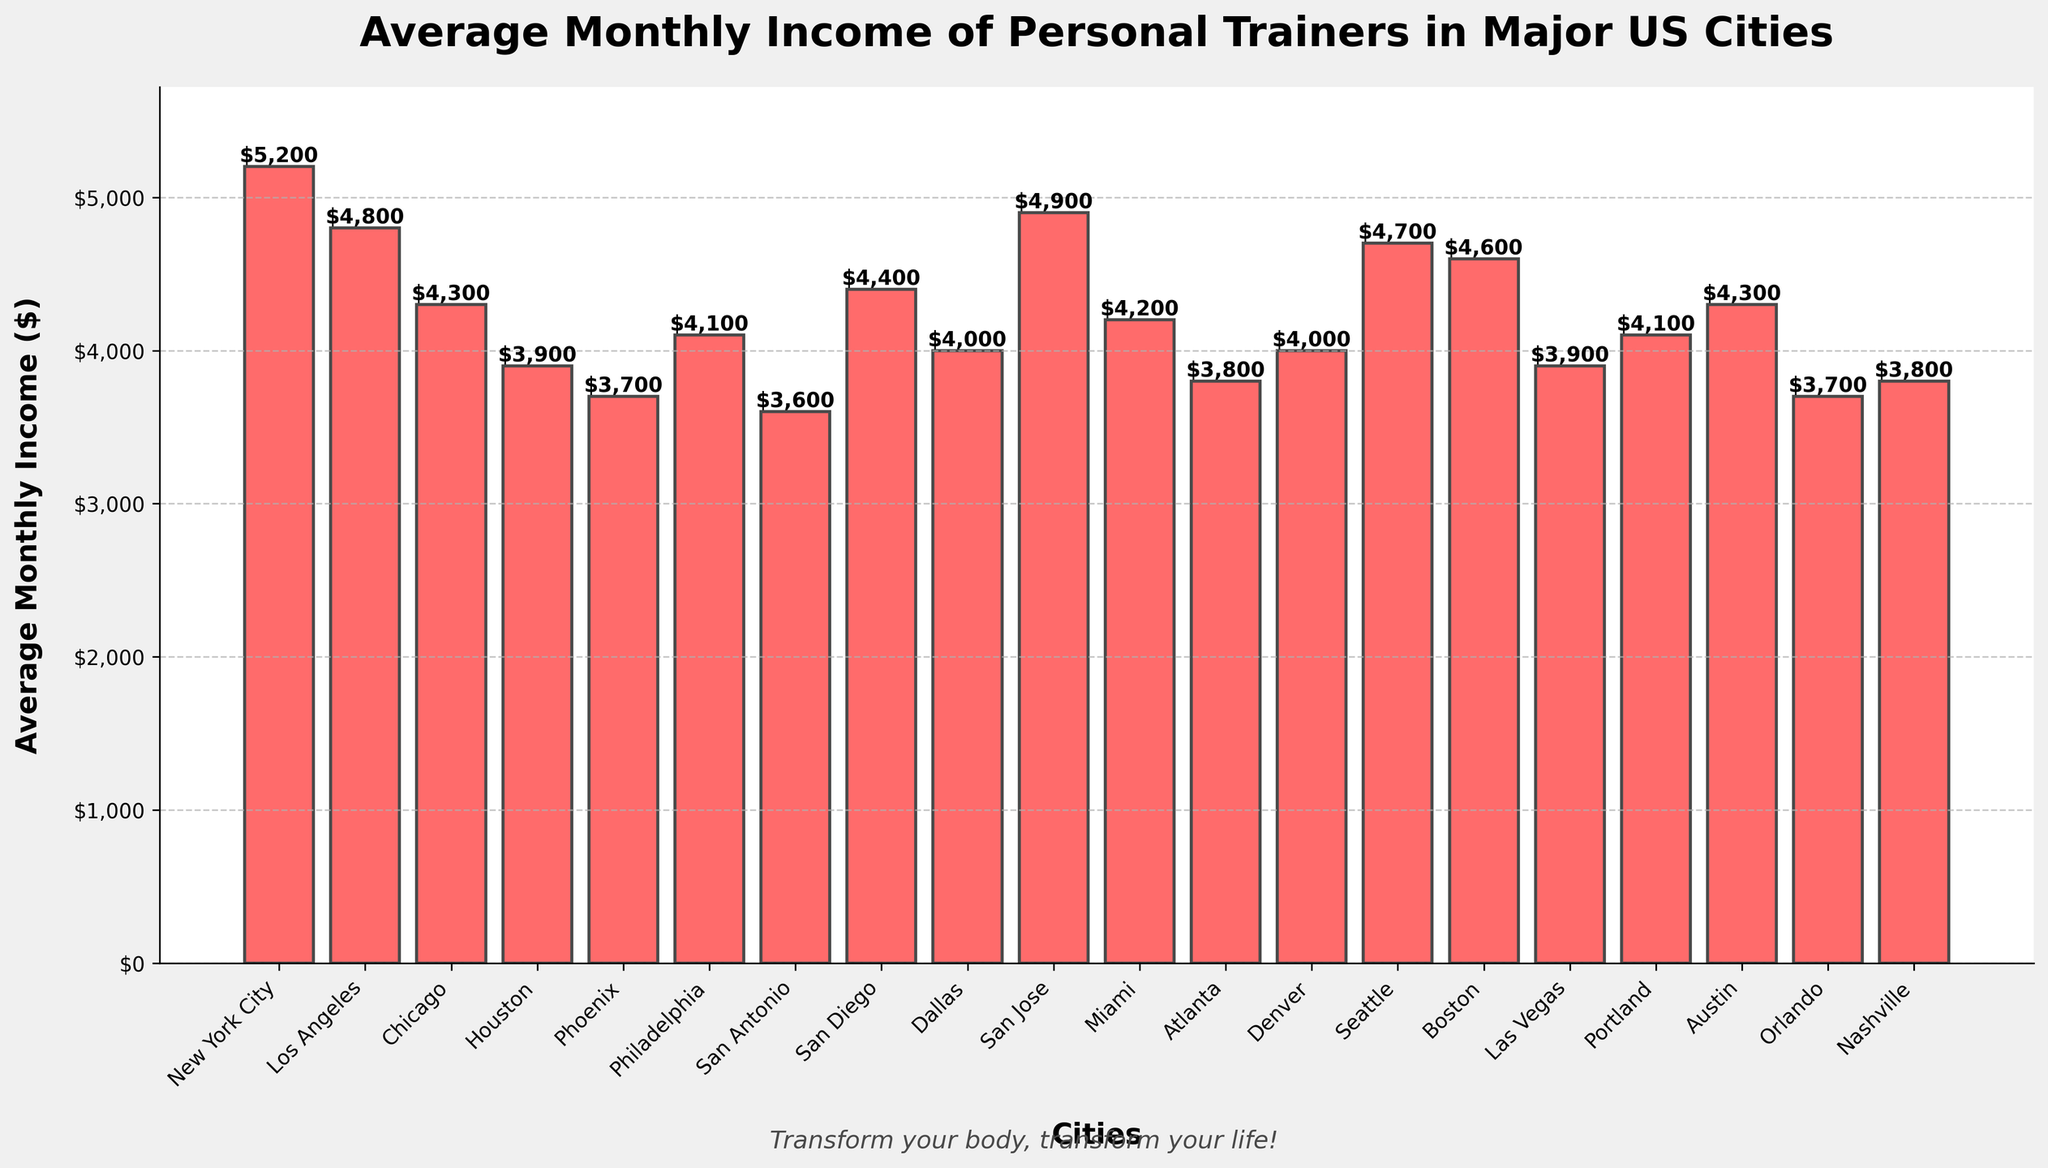What's the city with the highest average monthly income for personal trainers? The bar representing New York City is the tallest among all the bars in the plot. This indicates that New York City has the highest average monthly income for personal trainers.
Answer: New York City Which city has the lowest average monthly income? The bar representing San Antonio is among the shortest bars in the chart, making it clear that San Antonio has the lowest average monthly income for personal trainers.
Answer: San Antonio What's the difference in average monthly income between New York City and Los Angeles? The average monthly income in New York City is $5200, and in Los Angeles, it is $4800. The difference is calculated as $5200 - $4800.
Answer: $400 What's the average monthly income for personal trainers in cities with at least $4500 average monthly income? The cities that meet the criteria are New York City ($5200), Los Angeles ($4800), San Jose ($4900), Seattle ($4700), and Boston ($4600). Adding these values gives $5200 + $4800 + $4900 + $4700 + $4600 = $24200. The number of cities is 5. Therefore, the average is $24200 / 5.
Answer: $4840 Are there any cities where the average monthly income is exactly $3700? By looking directly at the heights and values annotated on the bars, Phoenix and Orlando both have average monthly incomes of $3700.
Answer: Phoenix and Orlando How many cities have an average monthly income below $4000? By examining the bars, we see that there are 5 cities where the average monthly income is below $4000: Houston ($3900), Phoenix ($3700), San Antonio ($3600), Atlanta ($3800), and Nashville ($3800).
Answer: 5 Which city has a higher average monthly income, Miami or Portland? The height of the bar for Miami ($4200) is slightly taller than that of Portland ($4100), indicating that Miami has a higher average monthly income than Portland.
Answer: Miami What's the combined average monthly income for trainers in Dallas and Denver? The average monthly income in Dallas is $4000, and in Denver, it is also $4000. Their combined average monthly incomes are $4000 + $4000.
Answer: $8000 Among the cities with an income above $4500, which city has the second-highest income? The cities with average incomes above $4500 are New York City ($5200), Los Angeles ($4800), San Jose ($4900), Seattle ($4700), and Boston ($4600). After New York City with the highest income, San Jose has the second-highest income at $4900.
Answer: San Jose Is the average monthly income in Philadelphia higher than in Atlanta? The bar for Philadelphia shows an income of $4100, whereas Atlanta shows $3800. This indicates that the average monthly income in Philadelphia is higher than in Atlanta.
Answer: Yes 